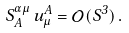Convert formula to latex. <formula><loc_0><loc_0><loc_500><loc_500>S _ { A } ^ { \alpha \mu } \, u ^ { A } _ { \mu } = \mathcal { O } ( S ^ { 3 } ) \, .</formula> 